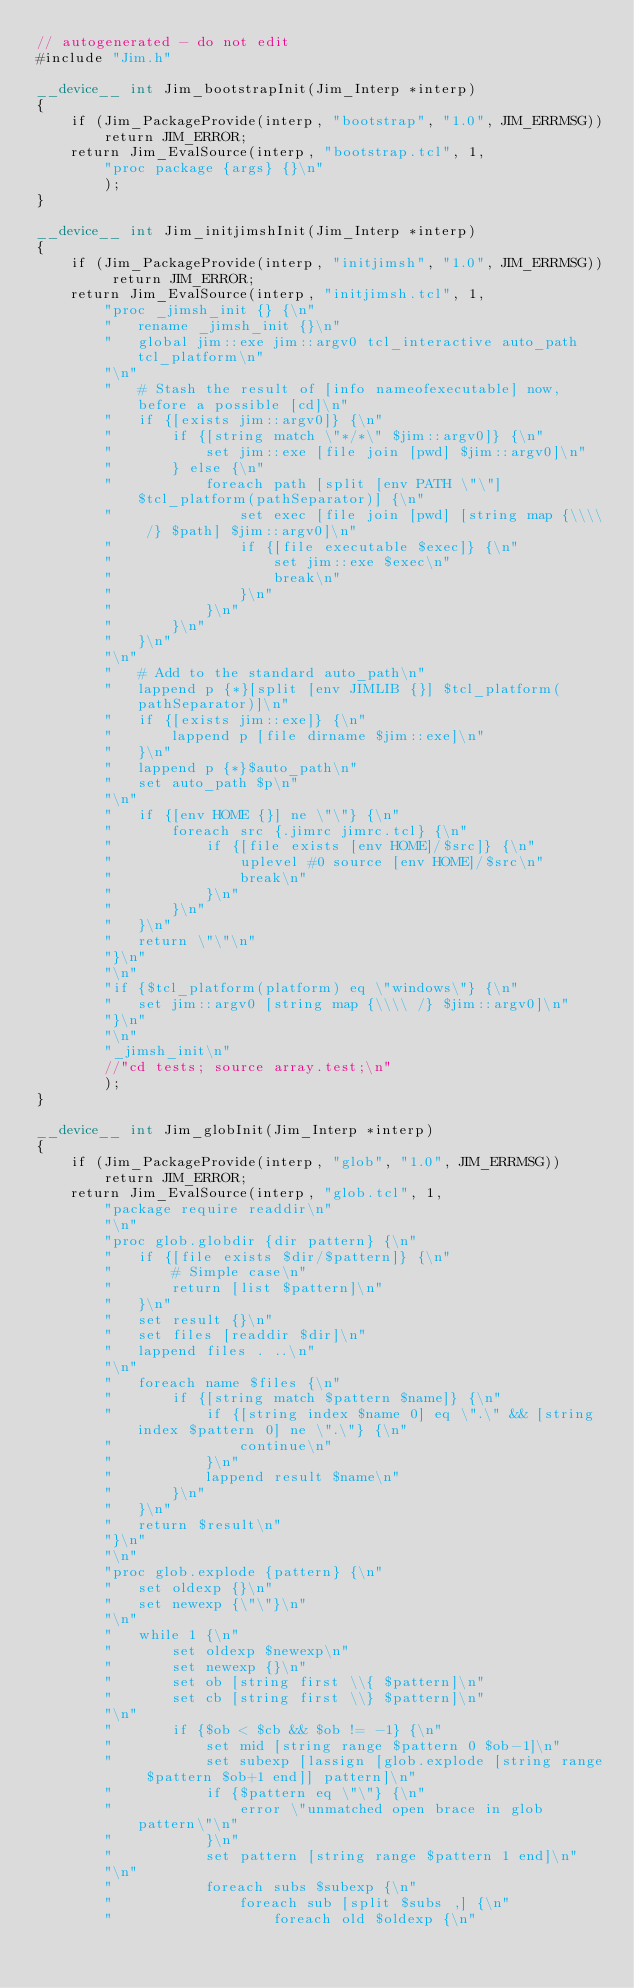<code> <loc_0><loc_0><loc_500><loc_500><_Cuda_>// autogenerated - do not edit
#include "Jim.h"

__device__ int Jim_bootstrapInit(Jim_Interp *interp)
{
	if (Jim_PackageProvide(interp, "bootstrap", "1.0", JIM_ERRMSG))
		return JIM_ERROR;
	return Jim_EvalSource(interp, "bootstrap.tcl", 1,
		"proc package {args} {}\n"
		);
}

__device__ int Jim_initjimshInit(Jim_Interp *interp)
{
	if (Jim_PackageProvide(interp, "initjimsh", "1.0", JIM_ERRMSG)) return JIM_ERROR;
	return Jim_EvalSource(interp, "initjimsh.tcl", 1,
		"proc _jimsh_init {} {\n"
		"	rename _jimsh_init {}\n"
		"	global jim::exe jim::argv0 tcl_interactive auto_path tcl_platform\n"
		"\n"
		"	# Stash the result of [info nameofexecutable] now, before a possible [cd]\n"
		"	if {[exists jim::argv0]} {\n"
		"		if {[string match \"*/*\" $jim::argv0]} {\n"
		"			set jim::exe [file join [pwd] $jim::argv0]\n"
		"		} else {\n"
		"			foreach path [split [env PATH \"\"] $tcl_platform(pathSeparator)] {\n"
		"				set exec [file join [pwd] [string map {\\\\ /} $path] $jim::argv0]\n"
		"				if {[file executable $exec]} {\n"
		"					set jim::exe $exec\n"
		"					break\n"
		"				}\n"
		"			}\n"
		"		}\n"
		"	}\n"
		"\n"
		"	# Add to the standard auto_path\n"
		"	lappend p {*}[split [env JIMLIB {}] $tcl_platform(pathSeparator)]\n"
		"	if {[exists jim::exe]} {\n"
		"		lappend p [file dirname $jim::exe]\n"
		"	}\n"
		"	lappend p {*}$auto_path\n"
		"	set auto_path $p\n"
		"\n"
		"	if {[env HOME {}] ne \"\"} {\n"
		"		foreach src {.jimrc jimrc.tcl} {\n"
		"			if {[file exists [env HOME]/$src]} {\n"
		"				uplevel #0 source [env HOME]/$src\n"
		"				break\n"
		"			}\n"
		"		}\n"
		"	}\n"
		"	return \"\"\n"
		"}\n"
		"\n"
		"if {$tcl_platform(platform) eq \"windows\"} {\n"
		"	set jim::argv0 [string map {\\\\ /} $jim::argv0]\n"
		"}\n"
		"\n"
		"_jimsh_init\n"
		//"cd tests; source array.test;\n"
		);
}

__device__ int Jim_globInit(Jim_Interp *interp)
{
	if (Jim_PackageProvide(interp, "glob", "1.0", JIM_ERRMSG))
		return JIM_ERROR;
	return Jim_EvalSource(interp, "glob.tcl", 1,
		"package require readdir\n"
		"\n"
		"proc glob.globdir {dir pattern} {\n"
		"	if {[file exists $dir/$pattern]} {\n"
		"		# Simple case\n"
		"		return [list $pattern]\n"
		"	}\n"
		"	set result {}\n"
		"	set files [readdir $dir]\n"
		"	lappend files . ..\n"
		"\n"
		"	foreach name $files {\n"
		"		if {[string match $pattern $name]} {\n"
		"			if {[string index $name 0] eq \".\" && [string index $pattern 0] ne \".\"} {\n"
		"				continue\n"
		"			}\n"
		"			lappend result $name\n"
		"		}\n"
		"	}\n"
		"	return $result\n"
		"}\n"
		"\n"
		"proc glob.explode {pattern} {\n"
		"	set oldexp {}\n"
		"	set newexp {\"\"}\n"
		"\n"
		"	while 1 {\n"
		"		set oldexp $newexp\n"
		"		set newexp {}\n"
		"		set ob [string first \\{ $pattern]\n"
		"		set cb [string first \\} $pattern]\n"
		"\n"
		"		if {$ob < $cb && $ob != -1} {\n"
		"			set mid [string range $pattern 0 $ob-1]\n"
		"			set subexp [lassign [glob.explode [string range $pattern $ob+1 end]] pattern]\n"
		"			if {$pattern eq \"\"} {\n"
		"				error \"unmatched open brace in glob pattern\"\n"
		"			}\n"
		"			set pattern [string range $pattern 1 end]\n"
		"\n"
		"			foreach subs $subexp {\n"
		"				foreach sub [split $subs ,] {\n"
		"					foreach old $oldexp {\n"</code> 